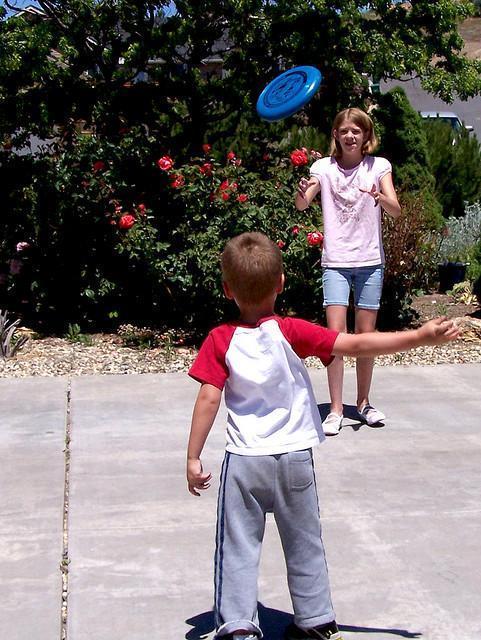How many people are in the picture?
Give a very brief answer. 2. How many shirts is the boy in front wearing?
Give a very brief answer. 1. How many people are visible?
Give a very brief answer. 2. How many suitcases are shown?
Give a very brief answer. 0. 